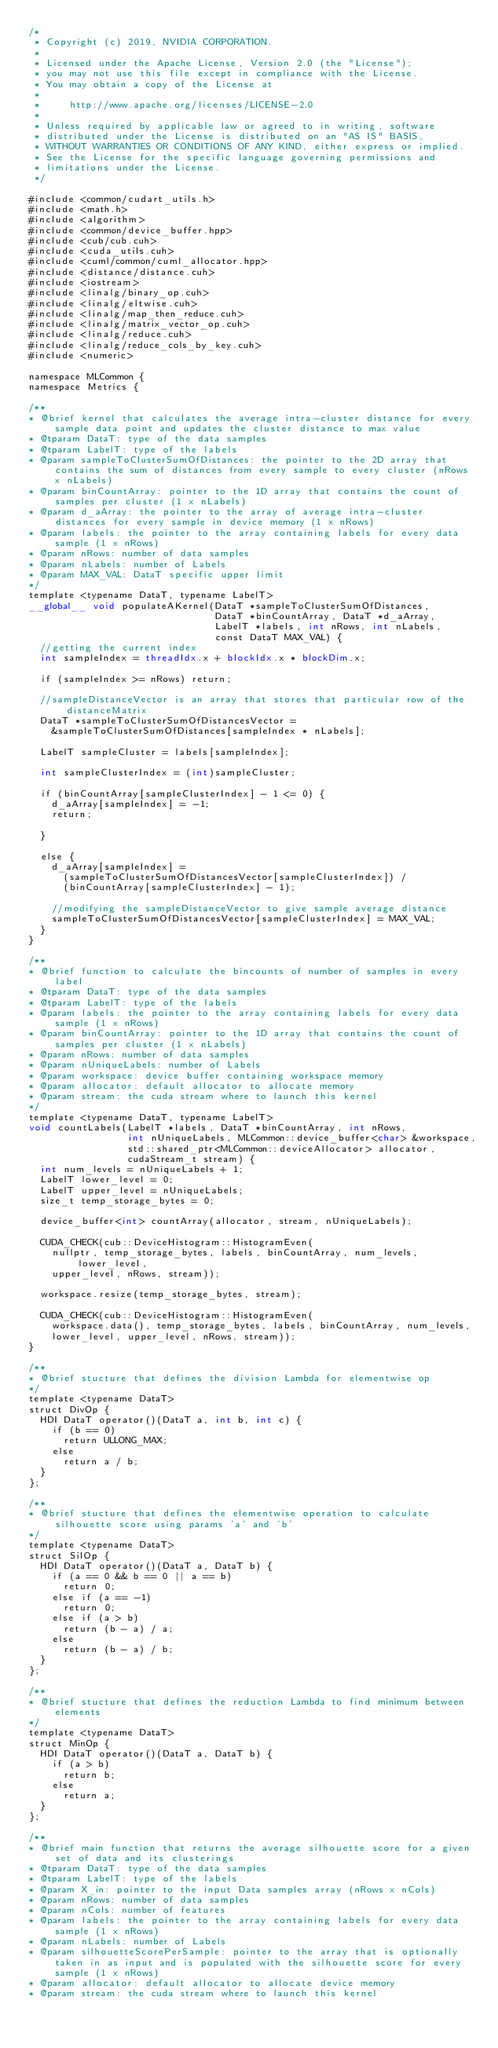<code> <loc_0><loc_0><loc_500><loc_500><_Cuda_>/*
 * Copyright (c) 2019, NVIDIA CORPORATION.
 *
 * Licensed under the Apache License, Version 2.0 (the "License");
 * you may not use this file except in compliance with the License.
 * You may obtain a copy of the License at
 *
 *     http://www.apache.org/licenses/LICENSE-2.0
 *
 * Unless required by applicable law or agreed to in writing, software
 * distributed under the License is distributed on an "AS IS" BASIS,
 * WITHOUT WARRANTIES OR CONDITIONS OF ANY KIND, either express or implied.
 * See the License for the specific language governing permissions and
 * limitations under the License.
 */

#include <common/cudart_utils.h>
#include <math.h>
#include <algorithm>
#include <common/device_buffer.hpp>
#include <cub/cub.cuh>
#include <cuda_utils.cuh>
#include <cuml/common/cuml_allocator.hpp>
#include <distance/distance.cuh>
#include <iostream>
#include <linalg/binary_op.cuh>
#include <linalg/eltwise.cuh>
#include <linalg/map_then_reduce.cuh>
#include <linalg/matrix_vector_op.cuh>
#include <linalg/reduce.cuh>
#include <linalg/reduce_cols_by_key.cuh>
#include <numeric>

namespace MLCommon {
namespace Metrics {

/**
* @brief kernel that calculates the average intra-cluster distance for every sample data point and updates the cluster distance to max value
* @tparam DataT: type of the data samples
* @tparam LabelT: type of the labels
* @param sampleToClusterSumOfDistances: the pointer to the 2D array that contains the sum of distances from every sample to every cluster (nRows x nLabels)
* @param binCountArray: pointer to the 1D array that contains the count of samples per cluster (1 x nLabels)
* @param d_aArray: the pointer to the array of average intra-cluster distances for every sample in device memory (1 x nRows)
* @param labels: the pointer to the array containing labels for every data sample (1 x nRows)
* @param nRows: number of data samples
* @param nLabels: number of Labels
* @param MAX_VAL: DataT specific upper limit
*/
template <typename DataT, typename LabelT>
__global__ void populateAKernel(DataT *sampleToClusterSumOfDistances,
                                DataT *binCountArray, DataT *d_aArray,
                                LabelT *labels, int nRows, int nLabels,
                                const DataT MAX_VAL) {
  //getting the current index
  int sampleIndex = threadIdx.x + blockIdx.x * blockDim.x;

  if (sampleIndex >= nRows) return;

  //sampleDistanceVector is an array that stores that particular row of the distanceMatrix
  DataT *sampleToClusterSumOfDistancesVector =
    &sampleToClusterSumOfDistances[sampleIndex * nLabels];

  LabelT sampleCluster = labels[sampleIndex];

  int sampleClusterIndex = (int)sampleCluster;

  if (binCountArray[sampleClusterIndex] - 1 <= 0) {
    d_aArray[sampleIndex] = -1;
    return;

  }

  else {
    d_aArray[sampleIndex] =
      (sampleToClusterSumOfDistancesVector[sampleClusterIndex]) /
      (binCountArray[sampleClusterIndex] - 1);

    //modifying the sampleDistanceVector to give sample average distance
    sampleToClusterSumOfDistancesVector[sampleClusterIndex] = MAX_VAL;
  }
}

/**
* @brief function to calculate the bincounts of number of samples in every label
* @tparam DataT: type of the data samples
* @tparam LabelT: type of the labels
* @param labels: the pointer to the array containing labels for every data sample (1 x nRows)
* @param binCountArray: pointer to the 1D array that contains the count of samples per cluster (1 x nLabels)
* @param nRows: number of data samples
* @param nUniqueLabels: number of Labels
* @param workspace: device buffer containing workspace memory
* @param allocator: default allocator to allocate memory
* @param stream: the cuda stream where to launch this kernel
*/
template <typename DataT, typename LabelT>
void countLabels(LabelT *labels, DataT *binCountArray, int nRows,
                 int nUniqueLabels, MLCommon::device_buffer<char> &workspace,
                 std::shared_ptr<MLCommon::deviceAllocator> allocator,
                 cudaStream_t stream) {
  int num_levels = nUniqueLabels + 1;
  LabelT lower_level = 0;
  LabelT upper_level = nUniqueLabels;
  size_t temp_storage_bytes = 0;

  device_buffer<int> countArray(allocator, stream, nUniqueLabels);

  CUDA_CHECK(cub::DeviceHistogram::HistogramEven(
    nullptr, temp_storage_bytes, labels, binCountArray, num_levels, lower_level,
    upper_level, nRows, stream));

  workspace.resize(temp_storage_bytes, stream);

  CUDA_CHECK(cub::DeviceHistogram::HistogramEven(
    workspace.data(), temp_storage_bytes, labels, binCountArray, num_levels,
    lower_level, upper_level, nRows, stream));
}

/**
* @brief stucture that defines the division Lambda for elementwise op
*/
template <typename DataT>
struct DivOp {
  HDI DataT operator()(DataT a, int b, int c) {
    if (b == 0)
      return ULLONG_MAX;
    else
      return a / b;
  }
};

/**
* @brief stucture that defines the elementwise operation to calculate silhouette score using params 'a' and 'b'
*/
template <typename DataT>
struct SilOp {
  HDI DataT operator()(DataT a, DataT b) {
    if (a == 0 && b == 0 || a == b)
      return 0;
    else if (a == -1)
      return 0;
    else if (a > b)
      return (b - a) / a;
    else
      return (b - a) / b;
  }
};

/**
* @brief stucture that defines the reduction Lambda to find minimum between elements
*/
template <typename DataT>
struct MinOp {
  HDI DataT operator()(DataT a, DataT b) {
    if (a > b)
      return b;
    else
      return a;
  }
};

/**
* @brief main function that returns the average silhouette score for a given set of data and its clusterings
* @tparam DataT: type of the data samples
* @tparam LabelT: type of the labels
* @param X_in: pointer to the input Data samples array (nRows x nCols)
* @param nRows: number of data samples
* @param nCols: number of features
* @param labels: the pointer to the array containing labels for every data sample (1 x nRows)
* @param nLabels: number of Labels
* @param silhouetteScorePerSample: pointer to the array that is optionally taken in as input and is populated with the silhouette score for every sample (1 x nRows)
* @param allocator: default allocator to allocate device memory
* @param stream: the cuda stream where to launch this kernel </code> 